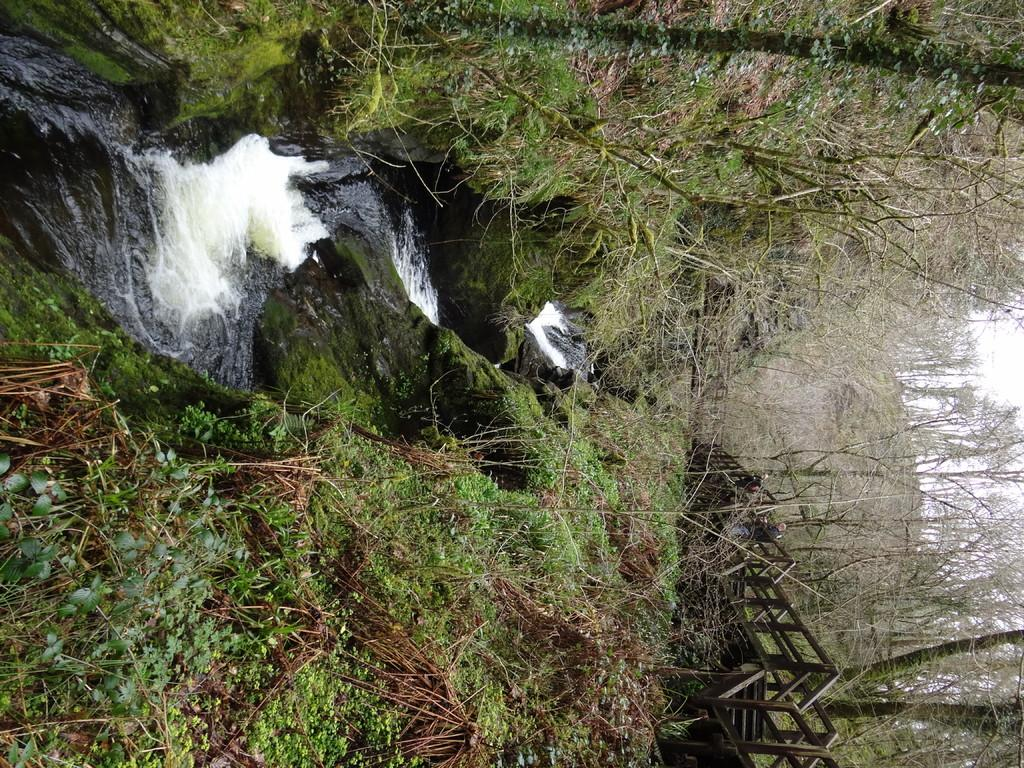How is the orientation of the image? The image is rotated. What can be seen in the middle of the image? There is a flow of water in the middle of the image. What type of vegetation is present in the image? Trees are present in the image. What type of ground cover is visible in the image? Grass is visible in the image. What type of structure is present in the image? There is a metal structure in the image. What is visible in the background of the image? The sky is visible in the background of the image. What type of skirt is being worn by the person in the image? There is no person present in the image, and therefore no skirt can be observed. What type of dinner is being served in the image? There is no dinner present in the image, and therefore no type of dinner can be determined. 